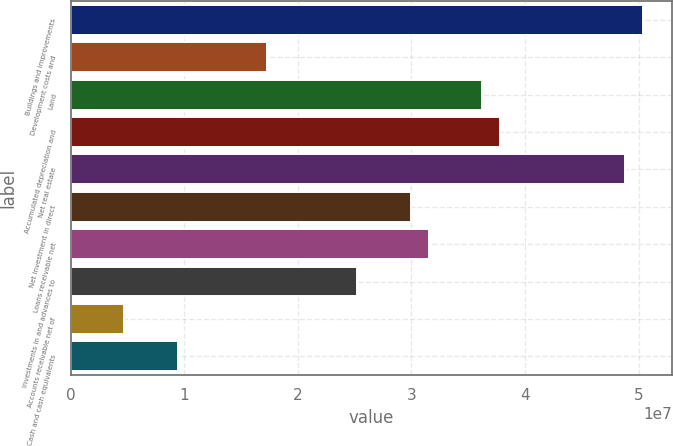<chart> <loc_0><loc_0><loc_500><loc_500><bar_chart><fcel>Buildings and improvements<fcel>Development costs and<fcel>Land<fcel>Accumulated depreciation and<fcel>Net real estate<fcel>Net investment in direct<fcel>Loans receivable net<fcel>Investments in and advances to<fcel>Accounts receivable net of<fcel>Cash and cash equivalents<nl><fcel>5.04213e+07<fcel>1.73348e+07<fcel>3.62414e+07<fcel>3.78169e+07<fcel>4.88458e+07<fcel>2.99392e+07<fcel>3.15148e+07<fcel>2.52126e+07<fcel>4.73042e+06<fcel>9.45707e+06<nl></chart> 